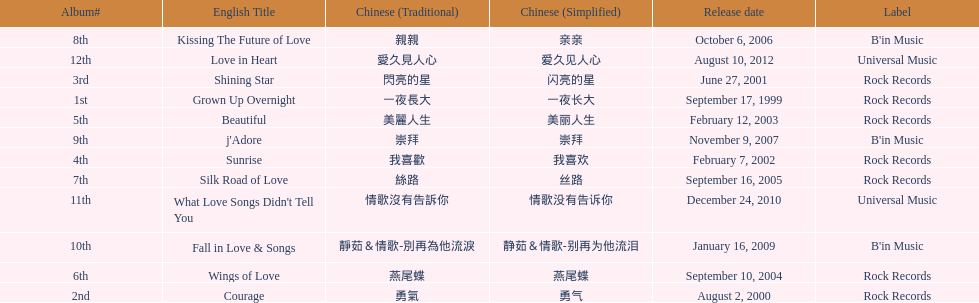Was the album beautiful released before the album love in heart? Yes. 